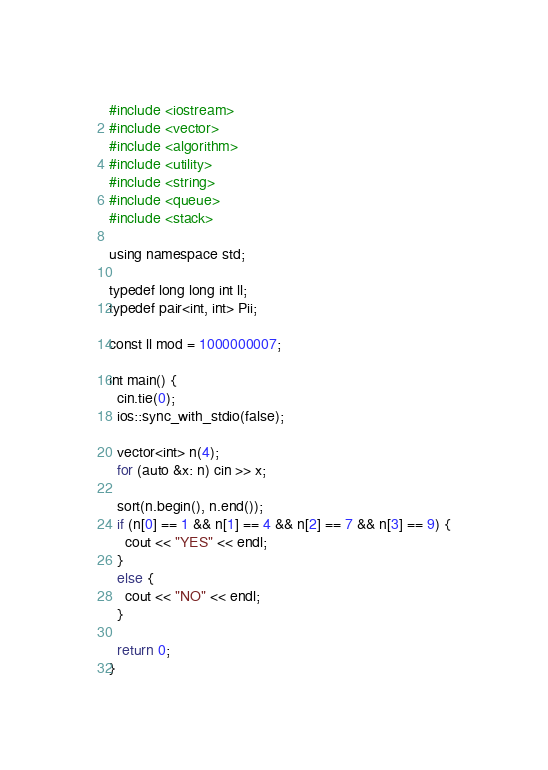<code> <loc_0><loc_0><loc_500><loc_500><_Python_>#include <iostream>
#include <vector>
#include <algorithm>
#include <utility>
#include <string>
#include <queue>
#include <stack>

using namespace std;

typedef long long int ll;
typedef pair<int, int> Pii;

const ll mod = 1000000007;

int main() {
  cin.tie(0);
  ios::sync_with_stdio(false);

  vector<int> n(4);
  for (auto &x: n) cin >> x;

  sort(n.begin(), n.end());
  if (n[0] == 1 && n[1] == 4 && n[2] == 7 && n[3] == 9) {
    cout << "YES" << endl;
  }
  else {
    cout << "NO" << endl;
  }

  return 0;
}
</code> 